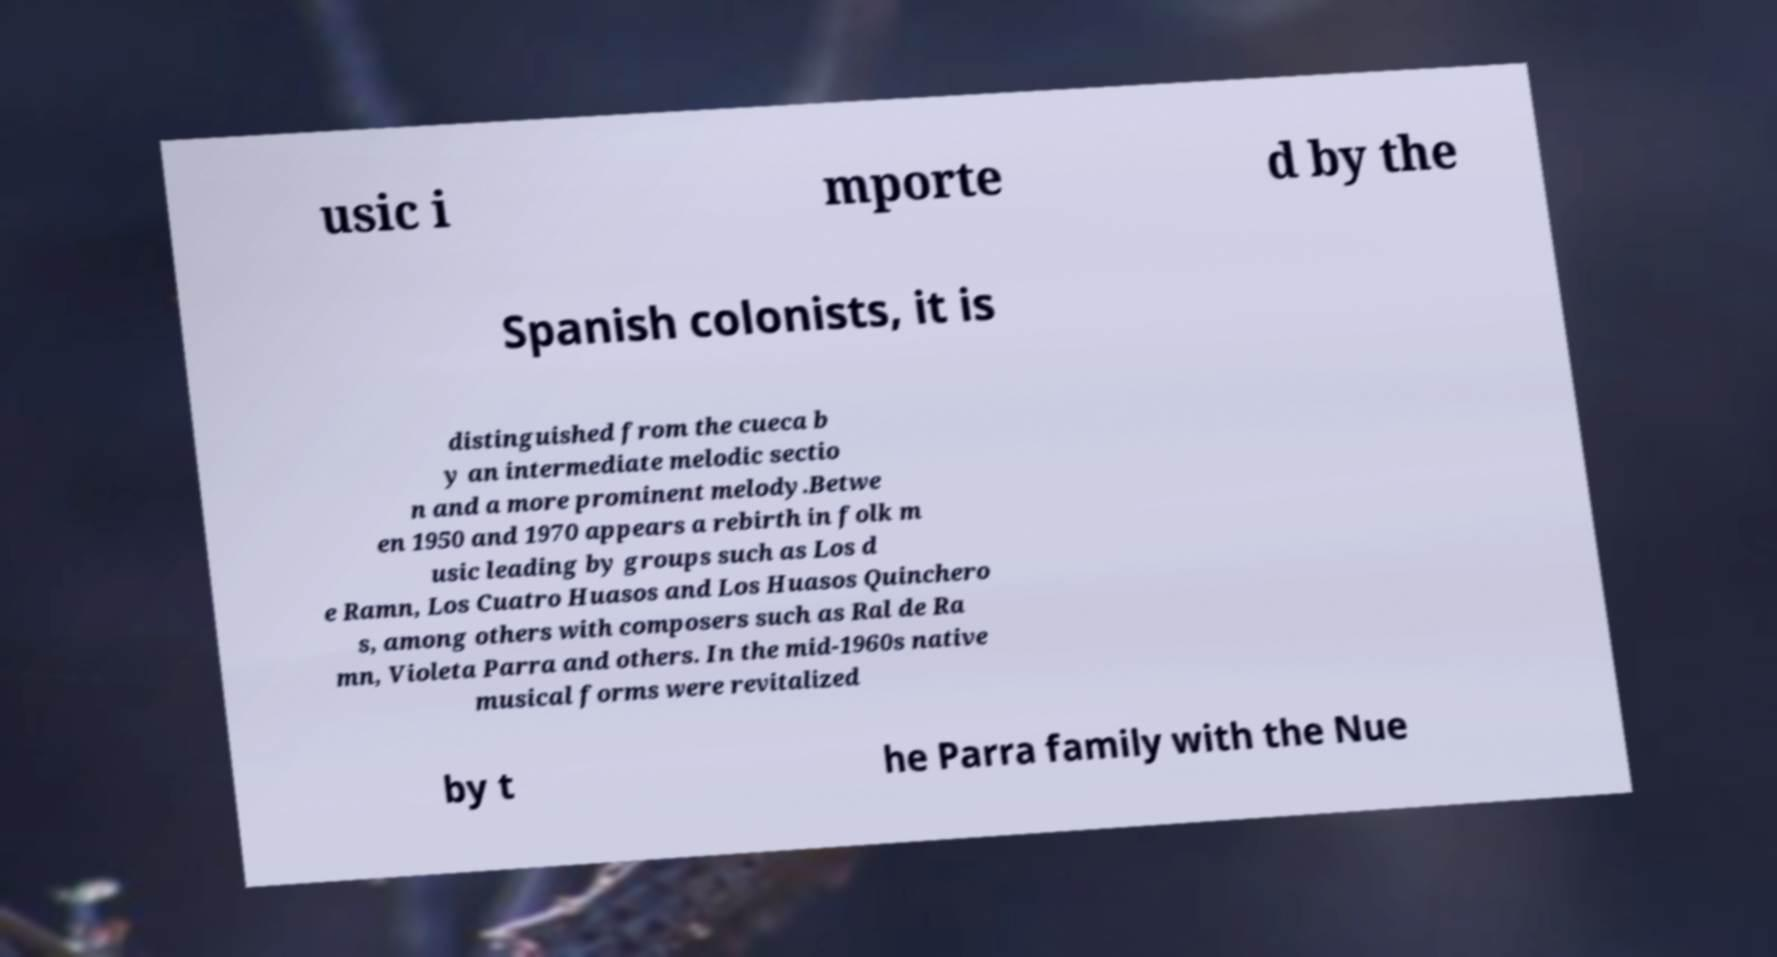Could you extract and type out the text from this image? usic i mporte d by the Spanish colonists, it is distinguished from the cueca b y an intermediate melodic sectio n and a more prominent melody.Betwe en 1950 and 1970 appears a rebirth in folk m usic leading by groups such as Los d e Ramn, Los Cuatro Huasos and Los Huasos Quinchero s, among others with composers such as Ral de Ra mn, Violeta Parra and others. In the mid-1960s native musical forms were revitalized by t he Parra family with the Nue 